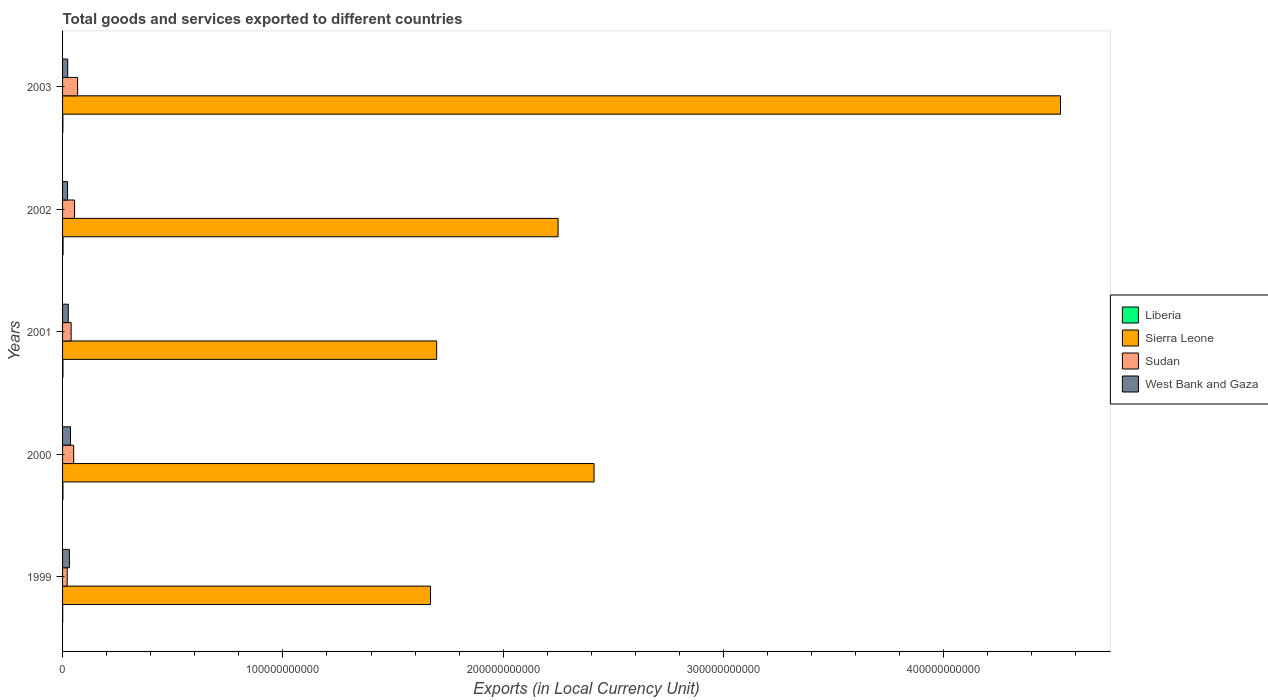How many different coloured bars are there?
Your response must be concise. 4. How many groups of bars are there?
Provide a succinct answer. 5. Are the number of bars on each tick of the Y-axis equal?
Your answer should be very brief. Yes. How many bars are there on the 2nd tick from the top?
Your answer should be compact. 4. What is the Amount of goods and services exports in Liberia in 1999?
Offer a terse response. 6.43e+07. Across all years, what is the maximum Amount of goods and services exports in Sierra Leone?
Provide a short and direct response. 4.53e+11. Across all years, what is the minimum Amount of goods and services exports in Liberia?
Offer a very short reply. 6.43e+07. In which year was the Amount of goods and services exports in West Bank and Gaza minimum?
Offer a very short reply. 2002. What is the total Amount of goods and services exports in Sudan in the graph?
Your answer should be very brief. 2.33e+1. What is the difference between the Amount of goods and services exports in Sierra Leone in 1999 and that in 2003?
Give a very brief answer. -2.86e+11. What is the difference between the Amount of goods and services exports in Sudan in 2000 and the Amount of goods and services exports in Sierra Leone in 2003?
Your response must be concise. -4.48e+11. What is the average Amount of goods and services exports in West Bank and Gaza per year?
Your response must be concise. 2.78e+09. In the year 1999, what is the difference between the Amount of goods and services exports in West Bank and Gaza and Amount of goods and services exports in Sierra Leone?
Keep it short and to the point. -1.64e+11. In how many years, is the Amount of goods and services exports in Sudan greater than 320000000000 LCU?
Keep it short and to the point. 0. What is the ratio of the Amount of goods and services exports in Sierra Leone in 1999 to that in 2002?
Your response must be concise. 0.74. Is the Amount of goods and services exports in Sudan in 2001 less than that in 2002?
Provide a short and direct response. Yes. Is the difference between the Amount of goods and services exports in West Bank and Gaza in 2002 and 2003 greater than the difference between the Amount of goods and services exports in Sierra Leone in 2002 and 2003?
Provide a short and direct response. Yes. What is the difference between the highest and the second highest Amount of goods and services exports in Sierra Leone?
Keep it short and to the point. 2.12e+11. What is the difference between the highest and the lowest Amount of goods and services exports in West Bank and Gaza?
Offer a terse response. 1.35e+09. In how many years, is the Amount of goods and services exports in Sudan greater than the average Amount of goods and services exports in Sudan taken over all years?
Your answer should be very brief. 3. Is the sum of the Amount of goods and services exports in Sudan in 1999 and 2003 greater than the maximum Amount of goods and services exports in West Bank and Gaza across all years?
Offer a terse response. Yes. What does the 1st bar from the top in 2003 represents?
Provide a short and direct response. West Bank and Gaza. What does the 2nd bar from the bottom in 2003 represents?
Your answer should be very brief. Sierra Leone. Is it the case that in every year, the sum of the Amount of goods and services exports in Sudan and Amount of goods and services exports in Sierra Leone is greater than the Amount of goods and services exports in Liberia?
Provide a succinct answer. Yes. What is the difference between two consecutive major ticks on the X-axis?
Make the answer very short. 1.00e+11. Are the values on the major ticks of X-axis written in scientific E-notation?
Make the answer very short. No. Does the graph contain any zero values?
Keep it short and to the point. No. Does the graph contain grids?
Make the answer very short. No. How many legend labels are there?
Provide a short and direct response. 4. What is the title of the graph?
Make the answer very short. Total goods and services exported to different countries. Does "South Sudan" appear as one of the legend labels in the graph?
Offer a very short reply. No. What is the label or title of the X-axis?
Provide a short and direct response. Exports (in Local Currency Unit). What is the Exports (in Local Currency Unit) of Liberia in 1999?
Keep it short and to the point. 6.43e+07. What is the Exports (in Local Currency Unit) in Sierra Leone in 1999?
Provide a short and direct response. 1.67e+11. What is the Exports (in Local Currency Unit) of Sudan in 1999?
Provide a short and direct response. 2.10e+09. What is the Exports (in Local Currency Unit) of West Bank and Gaza in 1999?
Ensure brevity in your answer.  3.11e+09. What is the Exports (in Local Currency Unit) of Liberia in 2000?
Provide a succinct answer. 1.66e+08. What is the Exports (in Local Currency Unit) of Sierra Leone in 2000?
Offer a very short reply. 2.41e+11. What is the Exports (in Local Currency Unit) in Sudan in 2000?
Offer a very short reply. 5.04e+09. What is the Exports (in Local Currency Unit) in West Bank and Gaza in 2000?
Offer a very short reply. 3.61e+09. What is the Exports (in Local Currency Unit) in Liberia in 2001?
Give a very brief answer. 1.77e+08. What is the Exports (in Local Currency Unit) of Sierra Leone in 2001?
Provide a short and direct response. 1.70e+11. What is the Exports (in Local Currency Unit) in Sudan in 2001?
Your answer should be very brief. 3.89e+09. What is the Exports (in Local Currency Unit) in West Bank and Gaza in 2001?
Make the answer very short. 2.59e+09. What is the Exports (in Local Currency Unit) in Liberia in 2002?
Offer a terse response. 2.30e+08. What is the Exports (in Local Currency Unit) in Sierra Leone in 2002?
Provide a succinct answer. 2.25e+11. What is the Exports (in Local Currency Unit) of Sudan in 2002?
Provide a short and direct response. 5.45e+09. What is the Exports (in Local Currency Unit) in West Bank and Gaza in 2002?
Offer a terse response. 2.26e+09. What is the Exports (in Local Currency Unit) in Liberia in 2003?
Offer a terse response. 1.50e+08. What is the Exports (in Local Currency Unit) in Sierra Leone in 2003?
Your answer should be very brief. 4.53e+11. What is the Exports (in Local Currency Unit) in Sudan in 2003?
Your answer should be compact. 6.83e+09. What is the Exports (in Local Currency Unit) in West Bank and Gaza in 2003?
Provide a short and direct response. 2.34e+09. Across all years, what is the maximum Exports (in Local Currency Unit) of Liberia?
Your answer should be compact. 2.30e+08. Across all years, what is the maximum Exports (in Local Currency Unit) in Sierra Leone?
Your answer should be very brief. 4.53e+11. Across all years, what is the maximum Exports (in Local Currency Unit) of Sudan?
Provide a succinct answer. 6.83e+09. Across all years, what is the maximum Exports (in Local Currency Unit) of West Bank and Gaza?
Offer a terse response. 3.61e+09. Across all years, what is the minimum Exports (in Local Currency Unit) in Liberia?
Give a very brief answer. 6.43e+07. Across all years, what is the minimum Exports (in Local Currency Unit) of Sierra Leone?
Make the answer very short. 1.67e+11. Across all years, what is the minimum Exports (in Local Currency Unit) of Sudan?
Your response must be concise. 2.10e+09. Across all years, what is the minimum Exports (in Local Currency Unit) in West Bank and Gaza?
Offer a terse response. 2.26e+09. What is the total Exports (in Local Currency Unit) of Liberia in the graph?
Your response must be concise. 7.87e+08. What is the total Exports (in Local Currency Unit) of Sierra Leone in the graph?
Ensure brevity in your answer.  1.26e+12. What is the total Exports (in Local Currency Unit) in Sudan in the graph?
Ensure brevity in your answer.  2.33e+1. What is the total Exports (in Local Currency Unit) in West Bank and Gaza in the graph?
Offer a terse response. 1.39e+1. What is the difference between the Exports (in Local Currency Unit) of Liberia in 1999 and that in 2000?
Offer a very short reply. -1.02e+08. What is the difference between the Exports (in Local Currency Unit) in Sierra Leone in 1999 and that in 2000?
Your answer should be compact. -7.42e+1. What is the difference between the Exports (in Local Currency Unit) of Sudan in 1999 and that in 2000?
Provide a succinct answer. -2.94e+09. What is the difference between the Exports (in Local Currency Unit) in West Bank and Gaza in 1999 and that in 2000?
Give a very brief answer. -4.99e+08. What is the difference between the Exports (in Local Currency Unit) in Liberia in 1999 and that in 2001?
Your answer should be compact. -1.13e+08. What is the difference between the Exports (in Local Currency Unit) of Sierra Leone in 1999 and that in 2001?
Offer a terse response. -2.80e+09. What is the difference between the Exports (in Local Currency Unit) in Sudan in 1999 and that in 2001?
Your answer should be compact. -1.79e+09. What is the difference between the Exports (in Local Currency Unit) of West Bank and Gaza in 1999 and that in 2001?
Your answer should be compact. 5.19e+08. What is the difference between the Exports (in Local Currency Unit) of Liberia in 1999 and that in 2002?
Offer a very short reply. -1.66e+08. What is the difference between the Exports (in Local Currency Unit) of Sierra Leone in 1999 and that in 2002?
Ensure brevity in your answer.  -5.79e+1. What is the difference between the Exports (in Local Currency Unit) in Sudan in 1999 and that in 2002?
Provide a succinct answer. -3.35e+09. What is the difference between the Exports (in Local Currency Unit) of West Bank and Gaza in 1999 and that in 2002?
Ensure brevity in your answer.  8.47e+08. What is the difference between the Exports (in Local Currency Unit) in Liberia in 1999 and that in 2003?
Your answer should be very brief. -8.57e+07. What is the difference between the Exports (in Local Currency Unit) in Sierra Leone in 1999 and that in 2003?
Your answer should be very brief. -2.86e+11. What is the difference between the Exports (in Local Currency Unit) in Sudan in 1999 and that in 2003?
Your response must be concise. -4.73e+09. What is the difference between the Exports (in Local Currency Unit) of West Bank and Gaza in 1999 and that in 2003?
Keep it short and to the point. 7.73e+08. What is the difference between the Exports (in Local Currency Unit) in Liberia in 2000 and that in 2001?
Your answer should be very brief. -1.10e+07. What is the difference between the Exports (in Local Currency Unit) in Sierra Leone in 2000 and that in 2001?
Your response must be concise. 7.14e+1. What is the difference between the Exports (in Local Currency Unit) in Sudan in 2000 and that in 2001?
Your answer should be compact. 1.15e+09. What is the difference between the Exports (in Local Currency Unit) in West Bank and Gaza in 2000 and that in 2001?
Make the answer very short. 1.02e+09. What is the difference between the Exports (in Local Currency Unit) in Liberia in 2000 and that in 2002?
Provide a short and direct response. -6.40e+07. What is the difference between the Exports (in Local Currency Unit) in Sierra Leone in 2000 and that in 2002?
Provide a succinct answer. 1.63e+1. What is the difference between the Exports (in Local Currency Unit) of Sudan in 2000 and that in 2002?
Your answer should be compact. -4.11e+08. What is the difference between the Exports (in Local Currency Unit) in West Bank and Gaza in 2000 and that in 2002?
Your answer should be very brief. 1.35e+09. What is the difference between the Exports (in Local Currency Unit) of Liberia in 2000 and that in 2003?
Keep it short and to the point. 1.60e+07. What is the difference between the Exports (in Local Currency Unit) in Sierra Leone in 2000 and that in 2003?
Make the answer very short. -2.12e+11. What is the difference between the Exports (in Local Currency Unit) of Sudan in 2000 and that in 2003?
Your response must be concise. -1.79e+09. What is the difference between the Exports (in Local Currency Unit) of West Bank and Gaza in 2000 and that in 2003?
Offer a very short reply. 1.27e+09. What is the difference between the Exports (in Local Currency Unit) of Liberia in 2001 and that in 2002?
Give a very brief answer. -5.30e+07. What is the difference between the Exports (in Local Currency Unit) of Sierra Leone in 2001 and that in 2002?
Offer a terse response. -5.51e+1. What is the difference between the Exports (in Local Currency Unit) of Sudan in 2001 and that in 2002?
Make the answer very short. -1.56e+09. What is the difference between the Exports (in Local Currency Unit) in West Bank and Gaza in 2001 and that in 2002?
Give a very brief answer. 3.28e+08. What is the difference between the Exports (in Local Currency Unit) of Liberia in 2001 and that in 2003?
Your response must be concise. 2.70e+07. What is the difference between the Exports (in Local Currency Unit) of Sierra Leone in 2001 and that in 2003?
Offer a very short reply. -2.83e+11. What is the difference between the Exports (in Local Currency Unit) in Sudan in 2001 and that in 2003?
Offer a terse response. -2.94e+09. What is the difference between the Exports (in Local Currency Unit) of West Bank and Gaza in 2001 and that in 2003?
Offer a terse response. 2.54e+08. What is the difference between the Exports (in Local Currency Unit) of Liberia in 2002 and that in 2003?
Your answer should be compact. 8.00e+07. What is the difference between the Exports (in Local Currency Unit) in Sierra Leone in 2002 and that in 2003?
Give a very brief answer. -2.28e+11. What is the difference between the Exports (in Local Currency Unit) of Sudan in 2002 and that in 2003?
Your answer should be very brief. -1.38e+09. What is the difference between the Exports (in Local Currency Unit) in West Bank and Gaza in 2002 and that in 2003?
Your answer should be compact. -7.38e+07. What is the difference between the Exports (in Local Currency Unit) in Liberia in 1999 and the Exports (in Local Currency Unit) in Sierra Leone in 2000?
Keep it short and to the point. -2.41e+11. What is the difference between the Exports (in Local Currency Unit) of Liberia in 1999 and the Exports (in Local Currency Unit) of Sudan in 2000?
Offer a terse response. -4.97e+09. What is the difference between the Exports (in Local Currency Unit) of Liberia in 1999 and the Exports (in Local Currency Unit) of West Bank and Gaza in 2000?
Offer a terse response. -3.55e+09. What is the difference between the Exports (in Local Currency Unit) of Sierra Leone in 1999 and the Exports (in Local Currency Unit) of Sudan in 2000?
Provide a short and direct response. 1.62e+11. What is the difference between the Exports (in Local Currency Unit) of Sierra Leone in 1999 and the Exports (in Local Currency Unit) of West Bank and Gaza in 2000?
Ensure brevity in your answer.  1.63e+11. What is the difference between the Exports (in Local Currency Unit) in Sudan in 1999 and the Exports (in Local Currency Unit) in West Bank and Gaza in 2000?
Offer a very short reply. -1.51e+09. What is the difference between the Exports (in Local Currency Unit) of Liberia in 1999 and the Exports (in Local Currency Unit) of Sierra Leone in 2001?
Provide a short and direct response. -1.70e+11. What is the difference between the Exports (in Local Currency Unit) of Liberia in 1999 and the Exports (in Local Currency Unit) of Sudan in 2001?
Your answer should be very brief. -3.82e+09. What is the difference between the Exports (in Local Currency Unit) in Liberia in 1999 and the Exports (in Local Currency Unit) in West Bank and Gaza in 2001?
Make the answer very short. -2.53e+09. What is the difference between the Exports (in Local Currency Unit) in Sierra Leone in 1999 and the Exports (in Local Currency Unit) in Sudan in 2001?
Offer a terse response. 1.63e+11. What is the difference between the Exports (in Local Currency Unit) in Sierra Leone in 1999 and the Exports (in Local Currency Unit) in West Bank and Gaza in 2001?
Provide a succinct answer. 1.64e+11. What is the difference between the Exports (in Local Currency Unit) in Sudan in 1999 and the Exports (in Local Currency Unit) in West Bank and Gaza in 2001?
Give a very brief answer. -4.94e+08. What is the difference between the Exports (in Local Currency Unit) of Liberia in 1999 and the Exports (in Local Currency Unit) of Sierra Leone in 2002?
Offer a terse response. -2.25e+11. What is the difference between the Exports (in Local Currency Unit) in Liberia in 1999 and the Exports (in Local Currency Unit) in Sudan in 2002?
Ensure brevity in your answer.  -5.38e+09. What is the difference between the Exports (in Local Currency Unit) in Liberia in 1999 and the Exports (in Local Currency Unit) in West Bank and Gaza in 2002?
Your response must be concise. -2.20e+09. What is the difference between the Exports (in Local Currency Unit) in Sierra Leone in 1999 and the Exports (in Local Currency Unit) in Sudan in 2002?
Offer a terse response. 1.62e+11. What is the difference between the Exports (in Local Currency Unit) of Sierra Leone in 1999 and the Exports (in Local Currency Unit) of West Bank and Gaza in 2002?
Keep it short and to the point. 1.65e+11. What is the difference between the Exports (in Local Currency Unit) of Sudan in 1999 and the Exports (in Local Currency Unit) of West Bank and Gaza in 2002?
Give a very brief answer. -1.66e+08. What is the difference between the Exports (in Local Currency Unit) of Liberia in 1999 and the Exports (in Local Currency Unit) of Sierra Leone in 2003?
Your answer should be very brief. -4.53e+11. What is the difference between the Exports (in Local Currency Unit) of Liberia in 1999 and the Exports (in Local Currency Unit) of Sudan in 2003?
Offer a very short reply. -6.76e+09. What is the difference between the Exports (in Local Currency Unit) of Liberia in 1999 and the Exports (in Local Currency Unit) of West Bank and Gaza in 2003?
Provide a succinct answer. -2.27e+09. What is the difference between the Exports (in Local Currency Unit) of Sierra Leone in 1999 and the Exports (in Local Currency Unit) of Sudan in 2003?
Make the answer very short. 1.60e+11. What is the difference between the Exports (in Local Currency Unit) of Sierra Leone in 1999 and the Exports (in Local Currency Unit) of West Bank and Gaza in 2003?
Keep it short and to the point. 1.65e+11. What is the difference between the Exports (in Local Currency Unit) of Sudan in 1999 and the Exports (in Local Currency Unit) of West Bank and Gaza in 2003?
Make the answer very short. -2.40e+08. What is the difference between the Exports (in Local Currency Unit) in Liberia in 2000 and the Exports (in Local Currency Unit) in Sierra Leone in 2001?
Your answer should be very brief. -1.70e+11. What is the difference between the Exports (in Local Currency Unit) in Liberia in 2000 and the Exports (in Local Currency Unit) in Sudan in 2001?
Give a very brief answer. -3.72e+09. What is the difference between the Exports (in Local Currency Unit) in Liberia in 2000 and the Exports (in Local Currency Unit) in West Bank and Gaza in 2001?
Keep it short and to the point. -2.43e+09. What is the difference between the Exports (in Local Currency Unit) of Sierra Leone in 2000 and the Exports (in Local Currency Unit) of Sudan in 2001?
Your answer should be compact. 2.37e+11. What is the difference between the Exports (in Local Currency Unit) of Sierra Leone in 2000 and the Exports (in Local Currency Unit) of West Bank and Gaza in 2001?
Your answer should be very brief. 2.39e+11. What is the difference between the Exports (in Local Currency Unit) of Sudan in 2000 and the Exports (in Local Currency Unit) of West Bank and Gaza in 2001?
Your answer should be very brief. 2.44e+09. What is the difference between the Exports (in Local Currency Unit) of Liberia in 2000 and the Exports (in Local Currency Unit) of Sierra Leone in 2002?
Offer a very short reply. -2.25e+11. What is the difference between the Exports (in Local Currency Unit) of Liberia in 2000 and the Exports (in Local Currency Unit) of Sudan in 2002?
Your response must be concise. -5.28e+09. What is the difference between the Exports (in Local Currency Unit) in Liberia in 2000 and the Exports (in Local Currency Unit) in West Bank and Gaza in 2002?
Give a very brief answer. -2.10e+09. What is the difference between the Exports (in Local Currency Unit) of Sierra Leone in 2000 and the Exports (in Local Currency Unit) of Sudan in 2002?
Provide a short and direct response. 2.36e+11. What is the difference between the Exports (in Local Currency Unit) of Sierra Leone in 2000 and the Exports (in Local Currency Unit) of West Bank and Gaza in 2002?
Provide a succinct answer. 2.39e+11. What is the difference between the Exports (in Local Currency Unit) of Sudan in 2000 and the Exports (in Local Currency Unit) of West Bank and Gaza in 2002?
Provide a succinct answer. 2.77e+09. What is the difference between the Exports (in Local Currency Unit) in Liberia in 2000 and the Exports (in Local Currency Unit) in Sierra Leone in 2003?
Ensure brevity in your answer.  -4.53e+11. What is the difference between the Exports (in Local Currency Unit) in Liberia in 2000 and the Exports (in Local Currency Unit) in Sudan in 2003?
Offer a terse response. -6.66e+09. What is the difference between the Exports (in Local Currency Unit) of Liberia in 2000 and the Exports (in Local Currency Unit) of West Bank and Gaza in 2003?
Your response must be concise. -2.17e+09. What is the difference between the Exports (in Local Currency Unit) in Sierra Leone in 2000 and the Exports (in Local Currency Unit) in Sudan in 2003?
Make the answer very short. 2.34e+11. What is the difference between the Exports (in Local Currency Unit) of Sierra Leone in 2000 and the Exports (in Local Currency Unit) of West Bank and Gaza in 2003?
Your answer should be very brief. 2.39e+11. What is the difference between the Exports (in Local Currency Unit) in Sudan in 2000 and the Exports (in Local Currency Unit) in West Bank and Gaza in 2003?
Provide a succinct answer. 2.70e+09. What is the difference between the Exports (in Local Currency Unit) of Liberia in 2001 and the Exports (in Local Currency Unit) of Sierra Leone in 2002?
Provide a short and direct response. -2.25e+11. What is the difference between the Exports (in Local Currency Unit) in Liberia in 2001 and the Exports (in Local Currency Unit) in Sudan in 2002?
Your answer should be compact. -5.27e+09. What is the difference between the Exports (in Local Currency Unit) of Liberia in 2001 and the Exports (in Local Currency Unit) of West Bank and Gaza in 2002?
Provide a short and direct response. -2.09e+09. What is the difference between the Exports (in Local Currency Unit) of Sierra Leone in 2001 and the Exports (in Local Currency Unit) of Sudan in 2002?
Keep it short and to the point. 1.64e+11. What is the difference between the Exports (in Local Currency Unit) of Sierra Leone in 2001 and the Exports (in Local Currency Unit) of West Bank and Gaza in 2002?
Offer a very short reply. 1.68e+11. What is the difference between the Exports (in Local Currency Unit) of Sudan in 2001 and the Exports (in Local Currency Unit) of West Bank and Gaza in 2002?
Give a very brief answer. 1.62e+09. What is the difference between the Exports (in Local Currency Unit) in Liberia in 2001 and the Exports (in Local Currency Unit) in Sierra Leone in 2003?
Your answer should be compact. -4.53e+11. What is the difference between the Exports (in Local Currency Unit) in Liberia in 2001 and the Exports (in Local Currency Unit) in Sudan in 2003?
Keep it short and to the point. -6.65e+09. What is the difference between the Exports (in Local Currency Unit) in Liberia in 2001 and the Exports (in Local Currency Unit) in West Bank and Gaza in 2003?
Make the answer very short. -2.16e+09. What is the difference between the Exports (in Local Currency Unit) of Sierra Leone in 2001 and the Exports (in Local Currency Unit) of Sudan in 2003?
Your answer should be very brief. 1.63e+11. What is the difference between the Exports (in Local Currency Unit) of Sierra Leone in 2001 and the Exports (in Local Currency Unit) of West Bank and Gaza in 2003?
Keep it short and to the point. 1.67e+11. What is the difference between the Exports (in Local Currency Unit) in Sudan in 2001 and the Exports (in Local Currency Unit) in West Bank and Gaza in 2003?
Ensure brevity in your answer.  1.55e+09. What is the difference between the Exports (in Local Currency Unit) in Liberia in 2002 and the Exports (in Local Currency Unit) in Sierra Leone in 2003?
Keep it short and to the point. -4.53e+11. What is the difference between the Exports (in Local Currency Unit) of Liberia in 2002 and the Exports (in Local Currency Unit) of Sudan in 2003?
Give a very brief answer. -6.60e+09. What is the difference between the Exports (in Local Currency Unit) of Liberia in 2002 and the Exports (in Local Currency Unit) of West Bank and Gaza in 2003?
Offer a terse response. -2.11e+09. What is the difference between the Exports (in Local Currency Unit) in Sierra Leone in 2002 and the Exports (in Local Currency Unit) in Sudan in 2003?
Make the answer very short. 2.18e+11. What is the difference between the Exports (in Local Currency Unit) in Sierra Leone in 2002 and the Exports (in Local Currency Unit) in West Bank and Gaza in 2003?
Ensure brevity in your answer.  2.23e+11. What is the difference between the Exports (in Local Currency Unit) in Sudan in 2002 and the Exports (in Local Currency Unit) in West Bank and Gaza in 2003?
Ensure brevity in your answer.  3.11e+09. What is the average Exports (in Local Currency Unit) of Liberia per year?
Ensure brevity in your answer.  1.57e+08. What is the average Exports (in Local Currency Unit) in Sierra Leone per year?
Provide a succinct answer. 2.51e+11. What is the average Exports (in Local Currency Unit) of Sudan per year?
Keep it short and to the point. 4.66e+09. What is the average Exports (in Local Currency Unit) of West Bank and Gaza per year?
Offer a terse response. 2.78e+09. In the year 1999, what is the difference between the Exports (in Local Currency Unit) in Liberia and Exports (in Local Currency Unit) in Sierra Leone?
Offer a terse response. -1.67e+11. In the year 1999, what is the difference between the Exports (in Local Currency Unit) of Liberia and Exports (in Local Currency Unit) of Sudan?
Ensure brevity in your answer.  -2.03e+09. In the year 1999, what is the difference between the Exports (in Local Currency Unit) in Liberia and Exports (in Local Currency Unit) in West Bank and Gaza?
Keep it short and to the point. -3.05e+09. In the year 1999, what is the difference between the Exports (in Local Currency Unit) in Sierra Leone and Exports (in Local Currency Unit) in Sudan?
Ensure brevity in your answer.  1.65e+11. In the year 1999, what is the difference between the Exports (in Local Currency Unit) of Sierra Leone and Exports (in Local Currency Unit) of West Bank and Gaza?
Keep it short and to the point. 1.64e+11. In the year 1999, what is the difference between the Exports (in Local Currency Unit) of Sudan and Exports (in Local Currency Unit) of West Bank and Gaza?
Provide a succinct answer. -1.01e+09. In the year 2000, what is the difference between the Exports (in Local Currency Unit) of Liberia and Exports (in Local Currency Unit) of Sierra Leone?
Your answer should be compact. -2.41e+11. In the year 2000, what is the difference between the Exports (in Local Currency Unit) of Liberia and Exports (in Local Currency Unit) of Sudan?
Your answer should be very brief. -4.87e+09. In the year 2000, what is the difference between the Exports (in Local Currency Unit) in Liberia and Exports (in Local Currency Unit) in West Bank and Gaza?
Keep it short and to the point. -3.44e+09. In the year 2000, what is the difference between the Exports (in Local Currency Unit) in Sierra Leone and Exports (in Local Currency Unit) in Sudan?
Ensure brevity in your answer.  2.36e+11. In the year 2000, what is the difference between the Exports (in Local Currency Unit) of Sierra Leone and Exports (in Local Currency Unit) of West Bank and Gaza?
Keep it short and to the point. 2.38e+11. In the year 2000, what is the difference between the Exports (in Local Currency Unit) of Sudan and Exports (in Local Currency Unit) of West Bank and Gaza?
Offer a very short reply. 1.43e+09. In the year 2001, what is the difference between the Exports (in Local Currency Unit) in Liberia and Exports (in Local Currency Unit) in Sierra Leone?
Provide a short and direct response. -1.70e+11. In the year 2001, what is the difference between the Exports (in Local Currency Unit) in Liberia and Exports (in Local Currency Unit) in Sudan?
Your answer should be compact. -3.71e+09. In the year 2001, what is the difference between the Exports (in Local Currency Unit) of Liberia and Exports (in Local Currency Unit) of West Bank and Gaza?
Give a very brief answer. -2.42e+09. In the year 2001, what is the difference between the Exports (in Local Currency Unit) in Sierra Leone and Exports (in Local Currency Unit) in Sudan?
Offer a very short reply. 1.66e+11. In the year 2001, what is the difference between the Exports (in Local Currency Unit) in Sierra Leone and Exports (in Local Currency Unit) in West Bank and Gaza?
Offer a very short reply. 1.67e+11. In the year 2001, what is the difference between the Exports (in Local Currency Unit) of Sudan and Exports (in Local Currency Unit) of West Bank and Gaza?
Ensure brevity in your answer.  1.29e+09. In the year 2002, what is the difference between the Exports (in Local Currency Unit) in Liberia and Exports (in Local Currency Unit) in Sierra Leone?
Provide a succinct answer. -2.25e+11. In the year 2002, what is the difference between the Exports (in Local Currency Unit) of Liberia and Exports (in Local Currency Unit) of Sudan?
Provide a succinct answer. -5.22e+09. In the year 2002, what is the difference between the Exports (in Local Currency Unit) of Liberia and Exports (in Local Currency Unit) of West Bank and Gaza?
Provide a short and direct response. -2.03e+09. In the year 2002, what is the difference between the Exports (in Local Currency Unit) in Sierra Leone and Exports (in Local Currency Unit) in Sudan?
Offer a very short reply. 2.19e+11. In the year 2002, what is the difference between the Exports (in Local Currency Unit) of Sierra Leone and Exports (in Local Currency Unit) of West Bank and Gaza?
Make the answer very short. 2.23e+11. In the year 2002, what is the difference between the Exports (in Local Currency Unit) of Sudan and Exports (in Local Currency Unit) of West Bank and Gaza?
Give a very brief answer. 3.18e+09. In the year 2003, what is the difference between the Exports (in Local Currency Unit) in Liberia and Exports (in Local Currency Unit) in Sierra Leone?
Offer a very short reply. -4.53e+11. In the year 2003, what is the difference between the Exports (in Local Currency Unit) in Liberia and Exports (in Local Currency Unit) in Sudan?
Give a very brief answer. -6.68e+09. In the year 2003, what is the difference between the Exports (in Local Currency Unit) in Liberia and Exports (in Local Currency Unit) in West Bank and Gaza?
Offer a terse response. -2.19e+09. In the year 2003, what is the difference between the Exports (in Local Currency Unit) of Sierra Leone and Exports (in Local Currency Unit) of Sudan?
Offer a very short reply. 4.46e+11. In the year 2003, what is the difference between the Exports (in Local Currency Unit) of Sierra Leone and Exports (in Local Currency Unit) of West Bank and Gaza?
Provide a short and direct response. 4.51e+11. In the year 2003, what is the difference between the Exports (in Local Currency Unit) of Sudan and Exports (in Local Currency Unit) of West Bank and Gaza?
Give a very brief answer. 4.49e+09. What is the ratio of the Exports (in Local Currency Unit) of Liberia in 1999 to that in 2000?
Keep it short and to the point. 0.39. What is the ratio of the Exports (in Local Currency Unit) of Sierra Leone in 1999 to that in 2000?
Your answer should be compact. 0.69. What is the ratio of the Exports (in Local Currency Unit) in Sudan in 1999 to that in 2000?
Give a very brief answer. 0.42. What is the ratio of the Exports (in Local Currency Unit) of West Bank and Gaza in 1999 to that in 2000?
Your answer should be compact. 0.86. What is the ratio of the Exports (in Local Currency Unit) of Liberia in 1999 to that in 2001?
Make the answer very short. 0.36. What is the ratio of the Exports (in Local Currency Unit) in Sierra Leone in 1999 to that in 2001?
Keep it short and to the point. 0.98. What is the ratio of the Exports (in Local Currency Unit) of Sudan in 1999 to that in 2001?
Make the answer very short. 0.54. What is the ratio of the Exports (in Local Currency Unit) in Liberia in 1999 to that in 2002?
Your answer should be very brief. 0.28. What is the ratio of the Exports (in Local Currency Unit) in Sierra Leone in 1999 to that in 2002?
Offer a very short reply. 0.74. What is the ratio of the Exports (in Local Currency Unit) in Sudan in 1999 to that in 2002?
Your answer should be compact. 0.39. What is the ratio of the Exports (in Local Currency Unit) in West Bank and Gaza in 1999 to that in 2002?
Your answer should be very brief. 1.37. What is the ratio of the Exports (in Local Currency Unit) in Liberia in 1999 to that in 2003?
Your answer should be compact. 0.43. What is the ratio of the Exports (in Local Currency Unit) in Sierra Leone in 1999 to that in 2003?
Give a very brief answer. 0.37. What is the ratio of the Exports (in Local Currency Unit) in Sudan in 1999 to that in 2003?
Your response must be concise. 0.31. What is the ratio of the Exports (in Local Currency Unit) of West Bank and Gaza in 1999 to that in 2003?
Keep it short and to the point. 1.33. What is the ratio of the Exports (in Local Currency Unit) of Liberia in 2000 to that in 2001?
Make the answer very short. 0.94. What is the ratio of the Exports (in Local Currency Unit) of Sierra Leone in 2000 to that in 2001?
Your response must be concise. 1.42. What is the ratio of the Exports (in Local Currency Unit) in Sudan in 2000 to that in 2001?
Your answer should be very brief. 1.3. What is the ratio of the Exports (in Local Currency Unit) of West Bank and Gaza in 2000 to that in 2001?
Offer a very short reply. 1.39. What is the ratio of the Exports (in Local Currency Unit) of Liberia in 2000 to that in 2002?
Offer a very short reply. 0.72. What is the ratio of the Exports (in Local Currency Unit) of Sierra Leone in 2000 to that in 2002?
Ensure brevity in your answer.  1.07. What is the ratio of the Exports (in Local Currency Unit) of Sudan in 2000 to that in 2002?
Ensure brevity in your answer.  0.92. What is the ratio of the Exports (in Local Currency Unit) in West Bank and Gaza in 2000 to that in 2002?
Your answer should be very brief. 1.59. What is the ratio of the Exports (in Local Currency Unit) in Liberia in 2000 to that in 2003?
Ensure brevity in your answer.  1.11. What is the ratio of the Exports (in Local Currency Unit) in Sierra Leone in 2000 to that in 2003?
Your answer should be very brief. 0.53. What is the ratio of the Exports (in Local Currency Unit) of Sudan in 2000 to that in 2003?
Keep it short and to the point. 0.74. What is the ratio of the Exports (in Local Currency Unit) of West Bank and Gaza in 2000 to that in 2003?
Your response must be concise. 1.54. What is the ratio of the Exports (in Local Currency Unit) of Liberia in 2001 to that in 2002?
Offer a very short reply. 0.77. What is the ratio of the Exports (in Local Currency Unit) of Sierra Leone in 2001 to that in 2002?
Give a very brief answer. 0.76. What is the ratio of the Exports (in Local Currency Unit) in Sudan in 2001 to that in 2002?
Give a very brief answer. 0.71. What is the ratio of the Exports (in Local Currency Unit) of West Bank and Gaza in 2001 to that in 2002?
Your response must be concise. 1.14. What is the ratio of the Exports (in Local Currency Unit) in Liberia in 2001 to that in 2003?
Provide a short and direct response. 1.18. What is the ratio of the Exports (in Local Currency Unit) of Sierra Leone in 2001 to that in 2003?
Your answer should be very brief. 0.37. What is the ratio of the Exports (in Local Currency Unit) of Sudan in 2001 to that in 2003?
Keep it short and to the point. 0.57. What is the ratio of the Exports (in Local Currency Unit) in West Bank and Gaza in 2001 to that in 2003?
Give a very brief answer. 1.11. What is the ratio of the Exports (in Local Currency Unit) in Liberia in 2002 to that in 2003?
Provide a short and direct response. 1.53. What is the ratio of the Exports (in Local Currency Unit) of Sierra Leone in 2002 to that in 2003?
Keep it short and to the point. 0.5. What is the ratio of the Exports (in Local Currency Unit) of Sudan in 2002 to that in 2003?
Ensure brevity in your answer.  0.8. What is the ratio of the Exports (in Local Currency Unit) in West Bank and Gaza in 2002 to that in 2003?
Give a very brief answer. 0.97. What is the difference between the highest and the second highest Exports (in Local Currency Unit) of Liberia?
Ensure brevity in your answer.  5.30e+07. What is the difference between the highest and the second highest Exports (in Local Currency Unit) in Sierra Leone?
Keep it short and to the point. 2.12e+11. What is the difference between the highest and the second highest Exports (in Local Currency Unit) in Sudan?
Offer a terse response. 1.38e+09. What is the difference between the highest and the second highest Exports (in Local Currency Unit) of West Bank and Gaza?
Give a very brief answer. 4.99e+08. What is the difference between the highest and the lowest Exports (in Local Currency Unit) of Liberia?
Ensure brevity in your answer.  1.66e+08. What is the difference between the highest and the lowest Exports (in Local Currency Unit) in Sierra Leone?
Make the answer very short. 2.86e+11. What is the difference between the highest and the lowest Exports (in Local Currency Unit) in Sudan?
Ensure brevity in your answer.  4.73e+09. What is the difference between the highest and the lowest Exports (in Local Currency Unit) in West Bank and Gaza?
Keep it short and to the point. 1.35e+09. 